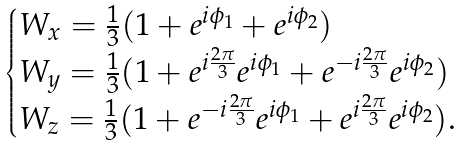<formula> <loc_0><loc_0><loc_500><loc_500>\begin{cases} W _ { x } = \frac { 1 } { 3 } ( 1 + e ^ { i \phi _ { 1 } } + e ^ { i \phi _ { 2 } } ) \\ W _ { y } = \frac { 1 } { 3 } ( 1 + e ^ { i \frac { 2 \pi } { 3 } } e ^ { i \phi _ { 1 } } + e ^ { - i \frac { 2 \pi } { 3 } } e ^ { i \phi _ { 2 } } ) \\ W _ { z } = \frac { 1 } { 3 } ( 1 + e ^ { - i \frac { 2 \pi } { 3 } } e ^ { i \phi _ { 1 } } + e ^ { i \frac { 2 \pi } { 3 } } e ^ { i \phi _ { 2 } } ) . \end{cases}</formula> 